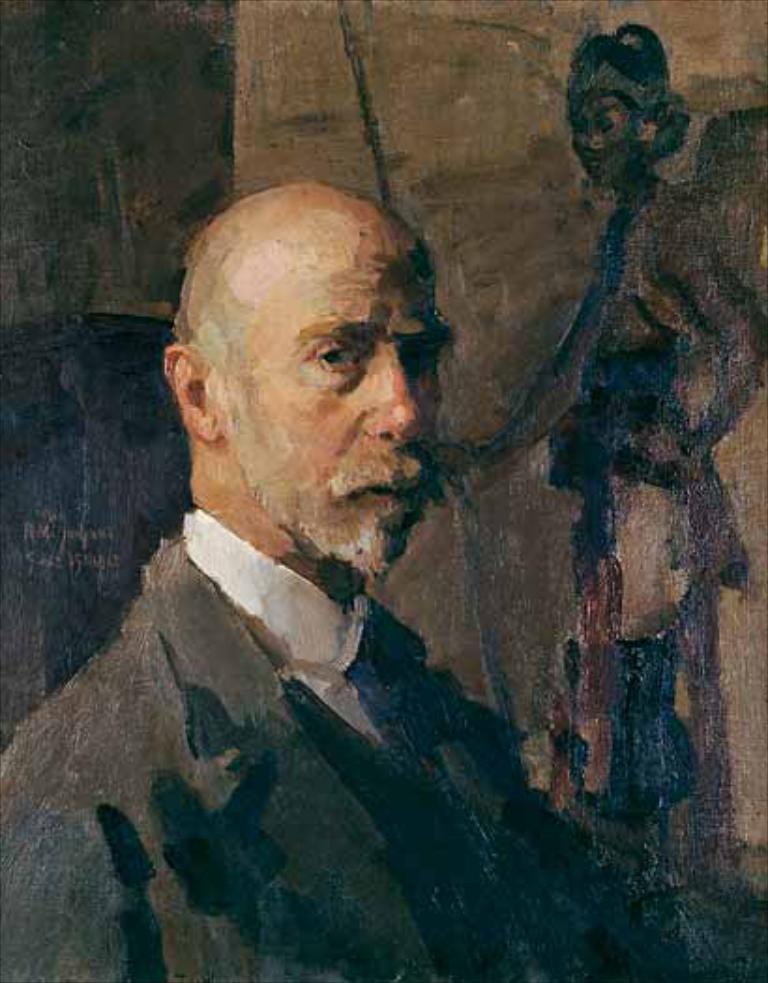Describe this image in one or two sentences. It is a blur picture of a man and behind the man there is some painting on a wall. 